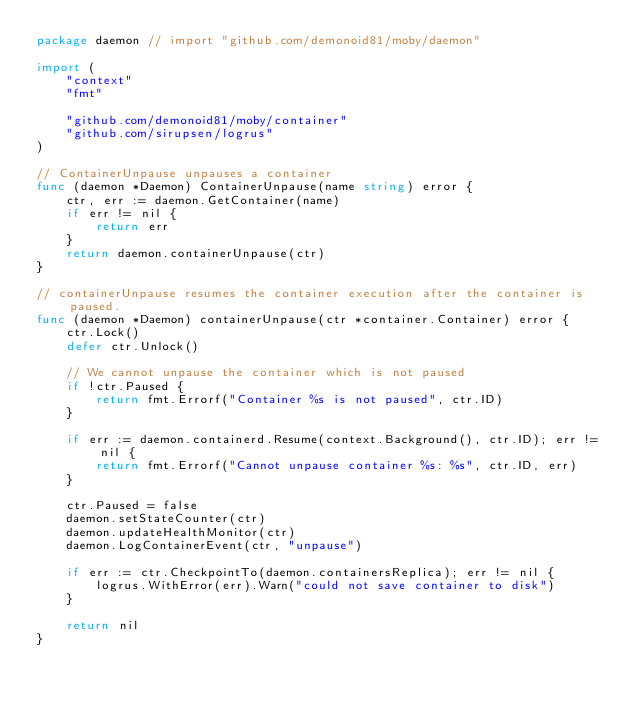Convert code to text. <code><loc_0><loc_0><loc_500><loc_500><_Go_>package daemon // import "github.com/demonoid81/moby/daemon"

import (
	"context"
	"fmt"

	"github.com/demonoid81/moby/container"
	"github.com/sirupsen/logrus"
)

// ContainerUnpause unpauses a container
func (daemon *Daemon) ContainerUnpause(name string) error {
	ctr, err := daemon.GetContainer(name)
	if err != nil {
		return err
	}
	return daemon.containerUnpause(ctr)
}

// containerUnpause resumes the container execution after the container is paused.
func (daemon *Daemon) containerUnpause(ctr *container.Container) error {
	ctr.Lock()
	defer ctr.Unlock()

	// We cannot unpause the container which is not paused
	if !ctr.Paused {
		return fmt.Errorf("Container %s is not paused", ctr.ID)
	}

	if err := daemon.containerd.Resume(context.Background(), ctr.ID); err != nil {
		return fmt.Errorf("Cannot unpause container %s: %s", ctr.ID, err)
	}

	ctr.Paused = false
	daemon.setStateCounter(ctr)
	daemon.updateHealthMonitor(ctr)
	daemon.LogContainerEvent(ctr, "unpause")

	if err := ctr.CheckpointTo(daemon.containersReplica); err != nil {
		logrus.WithError(err).Warn("could not save container to disk")
	}

	return nil
}
</code> 